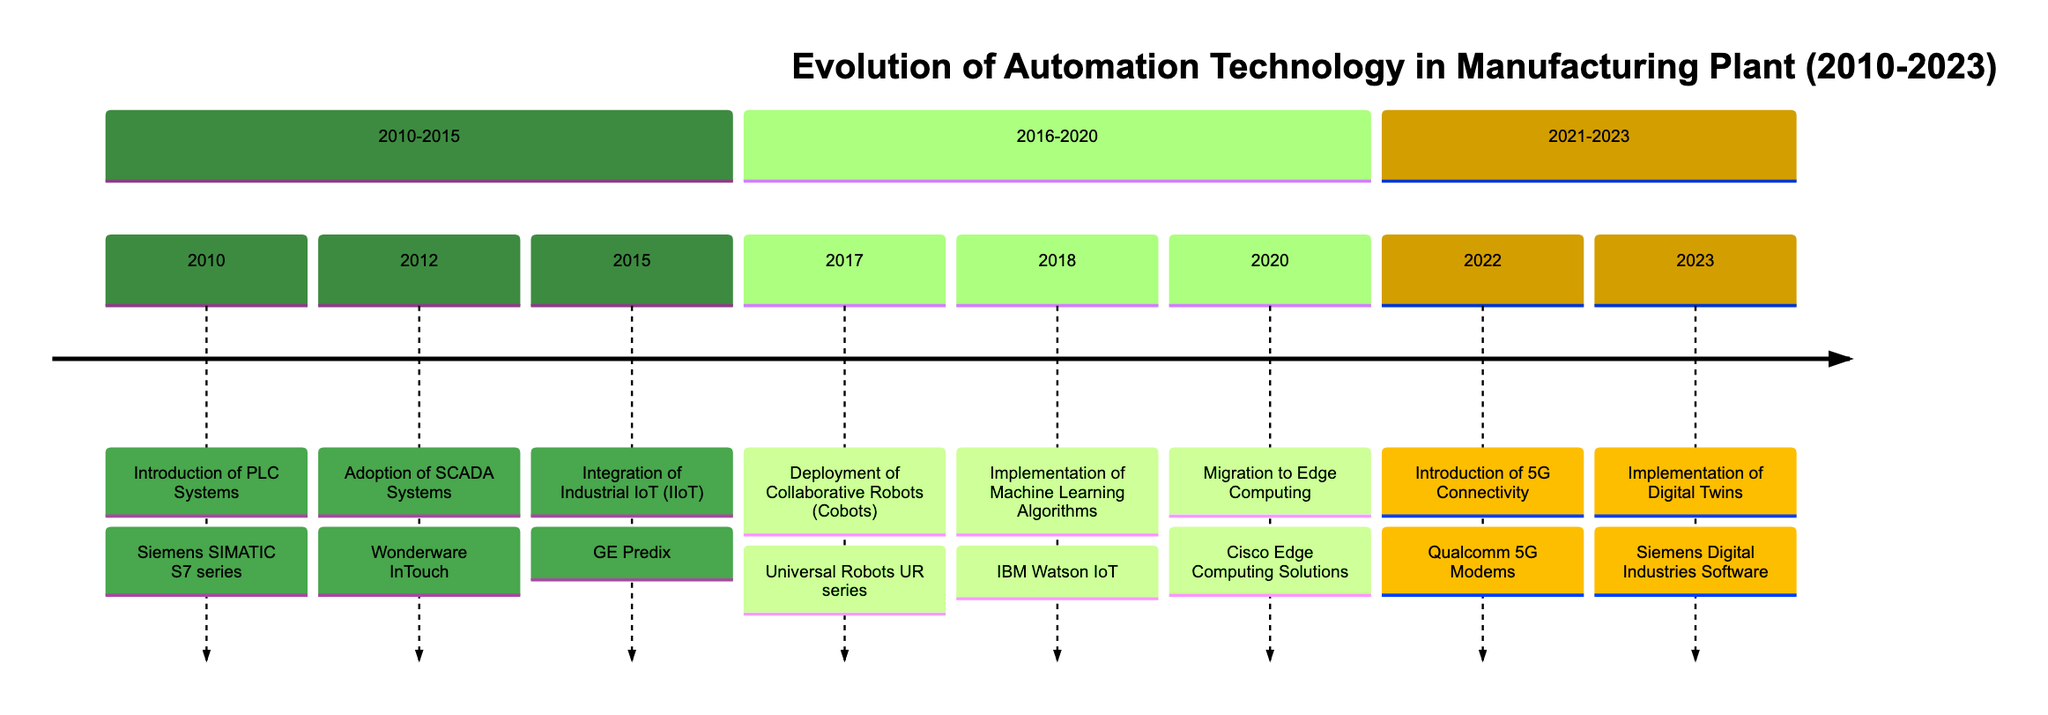What year was the introduction of PLC systems? The timeline clearly marks the year 2010 for the introduction of PLC systems. This event is positioned in the first section of the timeline.
Answer: 2010 Which technology was adopted in 2012? The timeline entry for the year 2012 specifies "Wonderware InTouch" as the technology associated with the adoption of SCADA systems, which is listed directly under that year.
Answer: Wonderware InTouch How many major automation events occurred between 2010 and 2015? By counting the events from the timeline section labeled "2010-2015," there are three specified dates (2010, 2012, and 2015) that represent major automation events.
Answer: 3 What technology is linked to the deployment of Collaborative Robots? In the timeline, the year 2017 records the deployment of Collaborative Robots, specifically linked to the technology "Universal Robots UR series," as indicated in the event description.
Answer: Universal Robots UR series What milestone event occurred in 2020? The timeline for the year 2020 indicates a significant milestone marked as "Migration to Edge Computing," which can be found in the section covering 2016-2020.
Answer: Migration to Edge Computing What is the last event listed in the timeline? The final year on the timeline is 2023, and it details the "Implementation of Digital Twins," indicating that this is the last milestone in the progression of automation technology.
Answer: Implementation of Digital Twins What technology was introduced in 2022, and why is it significant? The timeline indicates that "Qualcomm 5G Modems" were introduced for the event regarding 5G connectivity in 2022, highlighting its significance for faster machine-to-machine communication, based on the entry description.
Answer: Qualcomm 5G Modems How does the introduction of 5G connectivity in 2022 affect earlier technologies like IIoT? The introduction of 5G in 2022 enhances the performance of earlier technologies like IIoT by providing higher speeds and more reliable communication, as indicated by the chronological progression of the events on the timeline.
Answer: Enhanced performance In what year was machine learning integrated, and what is its associated technology? According to the timeline, the year 2018 marks the "Implementation of Machine Learning Algorithms," which is associated with the technology "IBM Watson IoT," as shown under that year.
Answer: IBM Watson IoT 